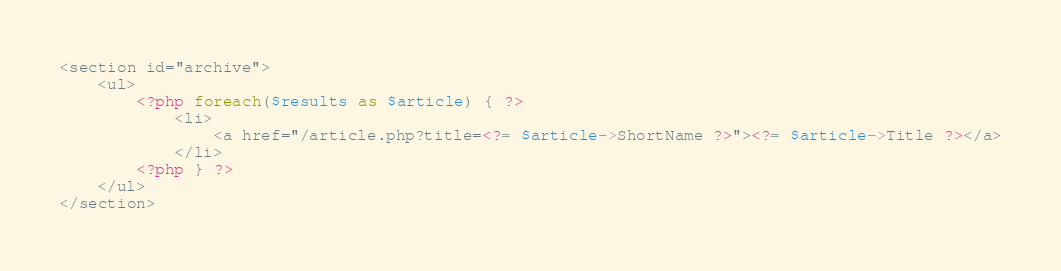Convert code to text. <code><loc_0><loc_0><loc_500><loc_500><_PHP_><section id="archive">
	<ul>
		<?php foreach($results as $article) { ?>
			<li>
				<a href="/article.php?title=<?= $article->ShortName ?>"><?= $article->Title ?></a>
			</li>
		<?php } ?>
	</ul>
</section>
</code> 